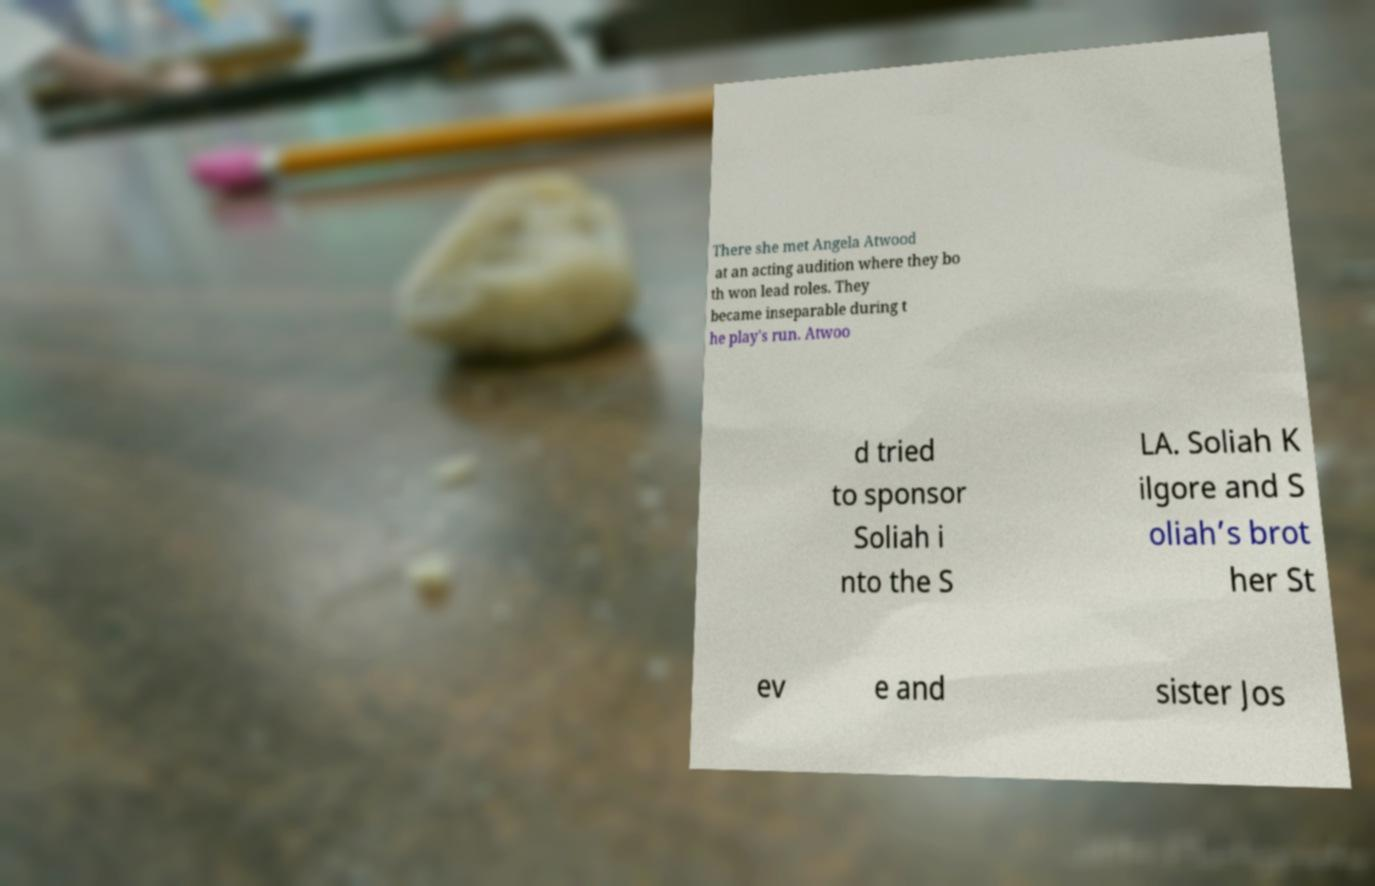Could you extract and type out the text from this image? There she met Angela Atwood at an acting audition where they bo th won lead roles. They became inseparable during t he play's run. Atwoo d tried to sponsor Soliah i nto the S LA. Soliah K ilgore and S oliah’s brot her St ev e and sister Jos 